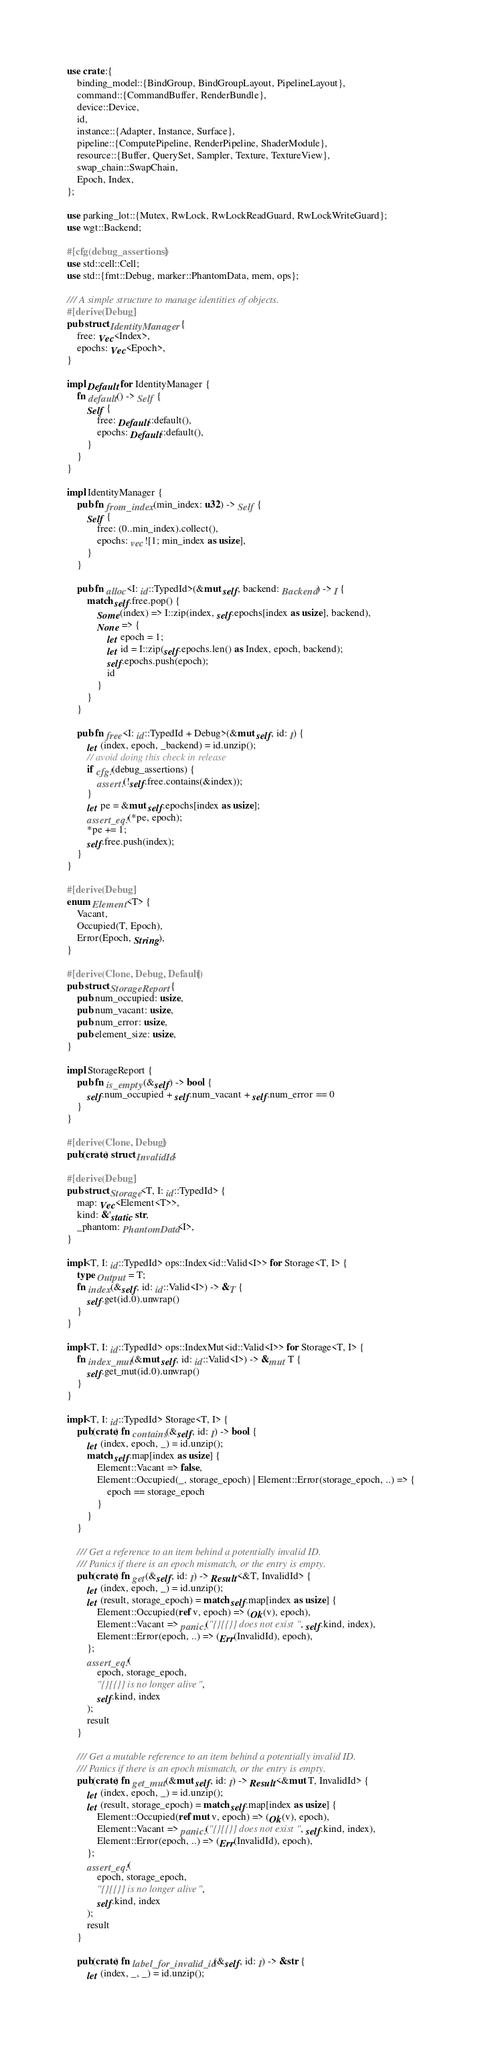<code> <loc_0><loc_0><loc_500><loc_500><_Rust_>use crate::{
    binding_model::{BindGroup, BindGroupLayout, PipelineLayout},
    command::{CommandBuffer, RenderBundle},
    device::Device,
    id,
    instance::{Adapter, Instance, Surface},
    pipeline::{ComputePipeline, RenderPipeline, ShaderModule},
    resource::{Buffer, QuerySet, Sampler, Texture, TextureView},
    swap_chain::SwapChain,
    Epoch, Index,
};

use parking_lot::{Mutex, RwLock, RwLockReadGuard, RwLockWriteGuard};
use wgt::Backend;

#[cfg(debug_assertions)]
use std::cell::Cell;
use std::{fmt::Debug, marker::PhantomData, mem, ops};

/// A simple structure to manage identities of objects.
#[derive(Debug)]
pub struct IdentityManager {
    free: Vec<Index>,
    epochs: Vec<Epoch>,
}

impl Default for IdentityManager {
    fn default() -> Self {
        Self {
            free: Default::default(),
            epochs: Default::default(),
        }
    }
}

impl IdentityManager {
    pub fn from_index(min_index: u32) -> Self {
        Self {
            free: (0..min_index).collect(),
            epochs: vec![1; min_index as usize],
        }
    }

    pub fn alloc<I: id::TypedId>(&mut self, backend: Backend) -> I {
        match self.free.pop() {
            Some(index) => I::zip(index, self.epochs[index as usize], backend),
            None => {
                let epoch = 1;
                let id = I::zip(self.epochs.len() as Index, epoch, backend);
                self.epochs.push(epoch);
                id
            }
        }
    }

    pub fn free<I: id::TypedId + Debug>(&mut self, id: I) {
        let (index, epoch, _backend) = id.unzip();
        // avoid doing this check in release
        if cfg!(debug_assertions) {
            assert!(!self.free.contains(&index));
        }
        let pe = &mut self.epochs[index as usize];
        assert_eq!(*pe, epoch);
        *pe += 1;
        self.free.push(index);
    }
}

#[derive(Debug)]
enum Element<T> {
    Vacant,
    Occupied(T, Epoch),
    Error(Epoch, String),
}

#[derive(Clone, Debug, Default)]
pub struct StorageReport {
    pub num_occupied: usize,
    pub num_vacant: usize,
    pub num_error: usize,
    pub element_size: usize,
}

impl StorageReport {
    pub fn is_empty(&self) -> bool {
        self.num_occupied + self.num_vacant + self.num_error == 0
    }
}

#[derive(Clone, Debug)]
pub(crate) struct InvalidId;

#[derive(Debug)]
pub struct Storage<T, I: id::TypedId> {
    map: Vec<Element<T>>,
    kind: &'static str,
    _phantom: PhantomData<I>,
}

impl<T, I: id::TypedId> ops::Index<id::Valid<I>> for Storage<T, I> {
    type Output = T;
    fn index(&self, id: id::Valid<I>) -> &T {
        self.get(id.0).unwrap()
    }
}

impl<T, I: id::TypedId> ops::IndexMut<id::Valid<I>> for Storage<T, I> {
    fn index_mut(&mut self, id: id::Valid<I>) -> &mut T {
        self.get_mut(id.0).unwrap()
    }
}

impl<T, I: id::TypedId> Storage<T, I> {
    pub(crate) fn contains(&self, id: I) -> bool {
        let (index, epoch, _) = id.unzip();
        match self.map[index as usize] {
            Element::Vacant => false,
            Element::Occupied(_, storage_epoch) | Element::Error(storage_epoch, ..) => {
                epoch == storage_epoch
            }
        }
    }

    /// Get a reference to an item behind a potentially invalid ID.
    /// Panics if there is an epoch mismatch, or the entry is empty.
    pub(crate) fn get(&self, id: I) -> Result<&T, InvalidId> {
        let (index, epoch, _) = id.unzip();
        let (result, storage_epoch) = match self.map[index as usize] {
            Element::Occupied(ref v, epoch) => (Ok(v), epoch),
            Element::Vacant => panic!("{}[{}] does not exist", self.kind, index),
            Element::Error(epoch, ..) => (Err(InvalidId), epoch),
        };
        assert_eq!(
            epoch, storage_epoch,
            "{}[{}] is no longer alive",
            self.kind, index
        );
        result
    }

    /// Get a mutable reference to an item behind a potentially invalid ID.
    /// Panics if there is an epoch mismatch, or the entry is empty.
    pub(crate) fn get_mut(&mut self, id: I) -> Result<&mut T, InvalidId> {
        let (index, epoch, _) = id.unzip();
        let (result, storage_epoch) = match self.map[index as usize] {
            Element::Occupied(ref mut v, epoch) => (Ok(v), epoch),
            Element::Vacant => panic!("{}[{}] does not exist", self.kind, index),
            Element::Error(epoch, ..) => (Err(InvalidId), epoch),
        };
        assert_eq!(
            epoch, storage_epoch,
            "{}[{}] is no longer alive",
            self.kind, index
        );
        result
    }

    pub(crate) fn label_for_invalid_id(&self, id: I) -> &str {
        let (index, _, _) = id.unzip();</code> 